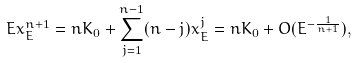<formula> <loc_0><loc_0><loc_500><loc_500>E x _ { E } ^ { n + 1 } = n K _ { 0 } + \sum _ { j = 1 } ^ { n - 1 } ( n - j ) x _ { E } ^ { j } = n K _ { 0 } + O ( E ^ { - \frac { 1 } { n + 1 } } ) ,</formula> 